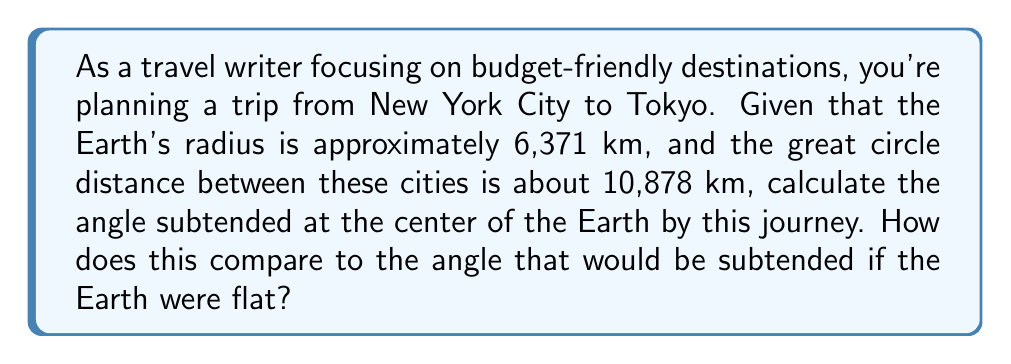Teach me how to tackle this problem. Let's approach this step-by-step:

1) For a spherical Earth, we can use the arc length formula:
   
   $s = r\theta$

   where $s$ is the arc length (great circle distance), $r$ is the radius, and $\theta$ is the angle in radians.

2) Rearranging the formula to solve for $\theta$:

   $\theta = \frac{s}{r}$

3) Plugging in our values:

   $\theta = \frac{10,878 \text{ km}}{6,371 \text{ km}} \approx 1.7075 \text{ radians}$

4) To convert to degrees:

   $\theta_{\text{degrees}} = \theta_{\text{radians}} \cdot \frac{180°}{\pi} \approx 97.82°$

5) For a flat Earth, the angle would be calculated using basic trigonometry:

   $\theta_{\text{flat}} = \tan^{-1}\left(\frac{s}{r}\right)$

6) Calculating:

   $\theta_{\text{flat}} = \tan^{-1}\left(\frac{10,878}{6,371}\right) \approx 1.0447 \text{ radians} \approx 59.84°$

7) The difference between these angles demonstrates the curvature of the Earth:

   $97.82° - 59.84° = 37.98°$

This significant difference highlights the importance of considering Earth's curvature for accurate long-distance travel calculations.
Answer: $97.82°$ (spherical Earth) vs $59.84°$ (flat Earth) 